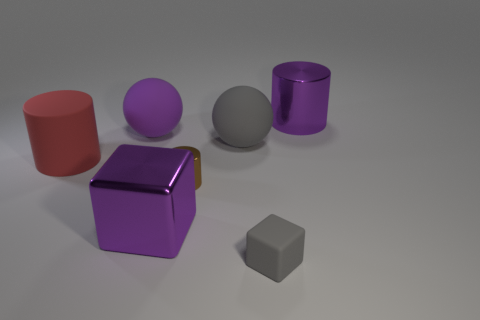Add 3 large rubber balls. How many objects exist? 10 Subtract all balls. How many objects are left? 5 Subtract 0 brown blocks. How many objects are left? 7 Subtract all blue matte cylinders. Subtract all big metal blocks. How many objects are left? 6 Add 3 matte cylinders. How many matte cylinders are left? 4 Add 1 big gray things. How many big gray things exist? 2 